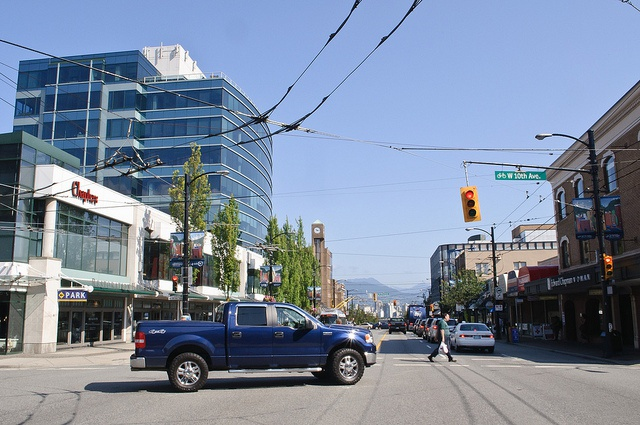Describe the objects in this image and their specific colors. I can see truck in darkgray, black, navy, and gray tones, car in darkgray, black, gray, and blue tones, people in darkgray, black, gray, and white tones, traffic light in darkgray, orange, brown, black, and maroon tones, and traffic light in darkgray, black, maroon, brown, and red tones in this image. 